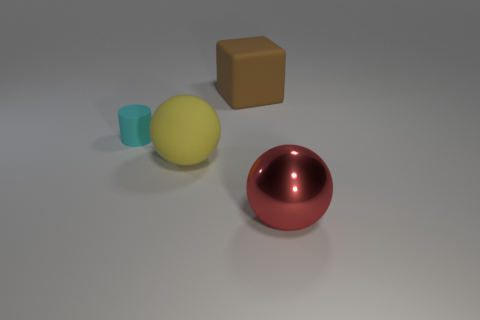What is the size of the yellow object that is made of the same material as the cyan cylinder?
Give a very brief answer. Large. How many other cyan things have the same shape as the small thing?
Keep it short and to the point. 0. Is the number of large yellow matte objects that are behind the large brown block greater than the number of brown shiny cubes?
Provide a succinct answer. No. What is the shape of the thing that is on the right side of the big yellow rubber thing and in front of the tiny cyan matte object?
Offer a terse response. Sphere. Is the red sphere the same size as the cylinder?
Your response must be concise. No. What number of small cyan things are in front of the yellow matte object?
Your answer should be compact. 0. Are there an equal number of tiny cyan matte cylinders that are in front of the red ball and matte blocks that are right of the yellow rubber thing?
Keep it short and to the point. No. There is a object on the right side of the brown matte cube; is its shape the same as the big yellow thing?
Keep it short and to the point. Yes. Is there any other thing that has the same material as the tiny cyan cylinder?
Your response must be concise. Yes. There is a yellow ball; does it have the same size as the matte thing that is to the left of the yellow matte thing?
Your response must be concise. No. 